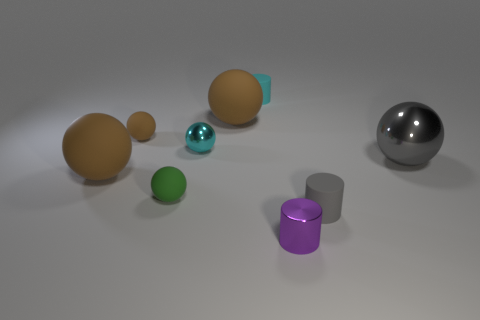Subtract all gray cubes. How many brown balls are left? 3 Subtract 2 balls. How many balls are left? 4 Subtract all small brown spheres. How many spheres are left? 5 Subtract all gray balls. How many balls are left? 5 Subtract all purple balls. Subtract all green blocks. How many balls are left? 6 Add 1 small cubes. How many objects exist? 10 Subtract all cylinders. How many objects are left? 6 Add 6 tiny cyan metallic things. How many tiny cyan metallic things exist? 7 Subtract 0 green cylinders. How many objects are left? 9 Subtract all large spheres. Subtract all tiny red metallic things. How many objects are left? 6 